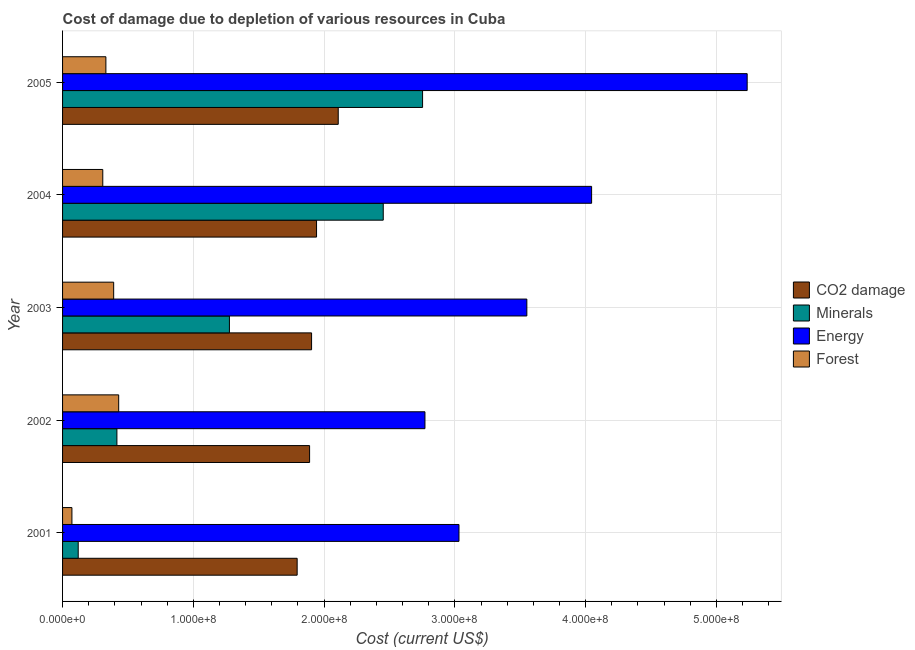How many different coloured bars are there?
Your answer should be compact. 4. Are the number of bars per tick equal to the number of legend labels?
Provide a short and direct response. Yes. Are the number of bars on each tick of the Y-axis equal?
Your response must be concise. Yes. How many bars are there on the 4th tick from the top?
Make the answer very short. 4. What is the label of the 1st group of bars from the top?
Offer a very short reply. 2005. What is the cost of damage due to depletion of forests in 2005?
Give a very brief answer. 3.31e+07. Across all years, what is the maximum cost of damage due to depletion of minerals?
Your response must be concise. 2.75e+08. Across all years, what is the minimum cost of damage due to depletion of forests?
Your answer should be compact. 7.16e+06. What is the total cost of damage due to depletion of minerals in the graph?
Provide a short and direct response. 7.02e+08. What is the difference between the cost of damage due to depletion of coal in 2002 and that in 2003?
Your answer should be very brief. -1.51e+06. What is the difference between the cost of damage due to depletion of energy in 2002 and the cost of damage due to depletion of coal in 2003?
Your response must be concise. 8.67e+07. What is the average cost of damage due to depletion of coal per year?
Keep it short and to the point. 1.93e+08. In the year 2005, what is the difference between the cost of damage due to depletion of coal and cost of damage due to depletion of forests?
Provide a short and direct response. 1.78e+08. What is the ratio of the cost of damage due to depletion of coal in 2004 to that in 2005?
Your response must be concise. 0.92. What is the difference between the highest and the second highest cost of damage due to depletion of energy?
Provide a succinct answer. 1.19e+08. What is the difference between the highest and the lowest cost of damage due to depletion of coal?
Ensure brevity in your answer.  3.14e+07. In how many years, is the cost of damage due to depletion of forests greater than the average cost of damage due to depletion of forests taken over all years?
Your answer should be compact. 4. What does the 2nd bar from the top in 2005 represents?
Give a very brief answer. Energy. What does the 2nd bar from the bottom in 2005 represents?
Your response must be concise. Minerals. How many bars are there?
Keep it short and to the point. 20. Are all the bars in the graph horizontal?
Offer a very short reply. Yes. Does the graph contain grids?
Make the answer very short. Yes. How are the legend labels stacked?
Provide a succinct answer. Vertical. What is the title of the graph?
Offer a terse response. Cost of damage due to depletion of various resources in Cuba . Does "UNTA" appear as one of the legend labels in the graph?
Offer a very short reply. No. What is the label or title of the X-axis?
Your answer should be very brief. Cost (current US$). What is the Cost (current US$) in CO2 damage in 2001?
Make the answer very short. 1.79e+08. What is the Cost (current US$) of Minerals in 2001?
Offer a very short reply. 1.20e+07. What is the Cost (current US$) of Energy in 2001?
Offer a terse response. 3.03e+08. What is the Cost (current US$) in Forest in 2001?
Make the answer very short. 7.16e+06. What is the Cost (current US$) of CO2 damage in 2002?
Give a very brief answer. 1.89e+08. What is the Cost (current US$) of Minerals in 2002?
Give a very brief answer. 4.16e+07. What is the Cost (current US$) of Energy in 2002?
Give a very brief answer. 2.77e+08. What is the Cost (current US$) in Forest in 2002?
Ensure brevity in your answer.  4.29e+07. What is the Cost (current US$) of CO2 damage in 2003?
Your answer should be very brief. 1.90e+08. What is the Cost (current US$) of Minerals in 2003?
Provide a succinct answer. 1.28e+08. What is the Cost (current US$) in Energy in 2003?
Provide a succinct answer. 3.55e+08. What is the Cost (current US$) of Forest in 2003?
Your response must be concise. 3.91e+07. What is the Cost (current US$) of CO2 damage in 2004?
Offer a very short reply. 1.94e+08. What is the Cost (current US$) in Minerals in 2004?
Ensure brevity in your answer.  2.45e+08. What is the Cost (current US$) in Energy in 2004?
Ensure brevity in your answer.  4.05e+08. What is the Cost (current US$) in Forest in 2004?
Keep it short and to the point. 3.08e+07. What is the Cost (current US$) of CO2 damage in 2005?
Your answer should be compact. 2.11e+08. What is the Cost (current US$) in Minerals in 2005?
Give a very brief answer. 2.75e+08. What is the Cost (current US$) of Energy in 2005?
Your answer should be very brief. 5.24e+08. What is the Cost (current US$) of Forest in 2005?
Offer a terse response. 3.31e+07. Across all years, what is the maximum Cost (current US$) of CO2 damage?
Your response must be concise. 2.11e+08. Across all years, what is the maximum Cost (current US$) of Minerals?
Offer a very short reply. 2.75e+08. Across all years, what is the maximum Cost (current US$) in Energy?
Offer a very short reply. 5.24e+08. Across all years, what is the maximum Cost (current US$) of Forest?
Make the answer very short. 4.29e+07. Across all years, what is the minimum Cost (current US$) in CO2 damage?
Give a very brief answer. 1.79e+08. Across all years, what is the minimum Cost (current US$) in Minerals?
Your response must be concise. 1.20e+07. Across all years, what is the minimum Cost (current US$) in Energy?
Your answer should be compact. 2.77e+08. Across all years, what is the minimum Cost (current US$) of Forest?
Provide a short and direct response. 7.16e+06. What is the total Cost (current US$) of CO2 damage in the graph?
Offer a terse response. 9.64e+08. What is the total Cost (current US$) of Minerals in the graph?
Your answer should be very brief. 7.02e+08. What is the total Cost (current US$) in Energy in the graph?
Make the answer very short. 1.86e+09. What is the total Cost (current US$) in Forest in the graph?
Provide a succinct answer. 1.53e+08. What is the difference between the Cost (current US$) of CO2 damage in 2001 and that in 2002?
Give a very brief answer. -9.51e+06. What is the difference between the Cost (current US$) of Minerals in 2001 and that in 2002?
Make the answer very short. -2.96e+07. What is the difference between the Cost (current US$) of Energy in 2001 and that in 2002?
Your answer should be compact. 2.60e+07. What is the difference between the Cost (current US$) of Forest in 2001 and that in 2002?
Your answer should be very brief. -3.58e+07. What is the difference between the Cost (current US$) in CO2 damage in 2001 and that in 2003?
Ensure brevity in your answer.  -1.10e+07. What is the difference between the Cost (current US$) of Minerals in 2001 and that in 2003?
Keep it short and to the point. -1.16e+08. What is the difference between the Cost (current US$) of Energy in 2001 and that in 2003?
Provide a succinct answer. -5.19e+07. What is the difference between the Cost (current US$) in Forest in 2001 and that in 2003?
Your answer should be compact. -3.19e+07. What is the difference between the Cost (current US$) in CO2 damage in 2001 and that in 2004?
Your response must be concise. -1.48e+07. What is the difference between the Cost (current US$) in Minerals in 2001 and that in 2004?
Offer a very short reply. -2.33e+08. What is the difference between the Cost (current US$) of Energy in 2001 and that in 2004?
Your answer should be very brief. -1.01e+08. What is the difference between the Cost (current US$) in Forest in 2001 and that in 2004?
Provide a short and direct response. -2.36e+07. What is the difference between the Cost (current US$) in CO2 damage in 2001 and that in 2005?
Offer a very short reply. -3.14e+07. What is the difference between the Cost (current US$) in Minerals in 2001 and that in 2005?
Your response must be concise. -2.63e+08. What is the difference between the Cost (current US$) of Energy in 2001 and that in 2005?
Your answer should be very brief. -2.20e+08. What is the difference between the Cost (current US$) in Forest in 2001 and that in 2005?
Your answer should be very brief. -2.60e+07. What is the difference between the Cost (current US$) of CO2 damage in 2002 and that in 2003?
Provide a short and direct response. -1.51e+06. What is the difference between the Cost (current US$) in Minerals in 2002 and that in 2003?
Offer a terse response. -8.60e+07. What is the difference between the Cost (current US$) in Energy in 2002 and that in 2003?
Offer a very short reply. -7.79e+07. What is the difference between the Cost (current US$) in Forest in 2002 and that in 2003?
Make the answer very short. 3.83e+06. What is the difference between the Cost (current US$) of CO2 damage in 2002 and that in 2004?
Ensure brevity in your answer.  -5.31e+06. What is the difference between the Cost (current US$) of Minerals in 2002 and that in 2004?
Provide a succinct answer. -2.04e+08. What is the difference between the Cost (current US$) in Energy in 2002 and that in 2004?
Your response must be concise. -1.27e+08. What is the difference between the Cost (current US$) in Forest in 2002 and that in 2004?
Offer a terse response. 1.22e+07. What is the difference between the Cost (current US$) of CO2 damage in 2002 and that in 2005?
Offer a very short reply. -2.19e+07. What is the difference between the Cost (current US$) in Minerals in 2002 and that in 2005?
Provide a short and direct response. -2.34e+08. What is the difference between the Cost (current US$) in Energy in 2002 and that in 2005?
Give a very brief answer. -2.46e+08. What is the difference between the Cost (current US$) in Forest in 2002 and that in 2005?
Your answer should be very brief. 9.78e+06. What is the difference between the Cost (current US$) in CO2 damage in 2003 and that in 2004?
Provide a succinct answer. -3.80e+06. What is the difference between the Cost (current US$) of Minerals in 2003 and that in 2004?
Ensure brevity in your answer.  -1.18e+08. What is the difference between the Cost (current US$) of Energy in 2003 and that in 2004?
Your answer should be compact. -4.95e+07. What is the difference between the Cost (current US$) in Forest in 2003 and that in 2004?
Your response must be concise. 8.33e+06. What is the difference between the Cost (current US$) of CO2 damage in 2003 and that in 2005?
Your answer should be very brief. -2.04e+07. What is the difference between the Cost (current US$) in Minerals in 2003 and that in 2005?
Ensure brevity in your answer.  -1.48e+08. What is the difference between the Cost (current US$) of Energy in 2003 and that in 2005?
Give a very brief answer. -1.68e+08. What is the difference between the Cost (current US$) in Forest in 2003 and that in 2005?
Offer a very short reply. 5.95e+06. What is the difference between the Cost (current US$) in CO2 damage in 2004 and that in 2005?
Ensure brevity in your answer.  -1.66e+07. What is the difference between the Cost (current US$) in Minerals in 2004 and that in 2005?
Provide a succinct answer. -3.01e+07. What is the difference between the Cost (current US$) in Energy in 2004 and that in 2005?
Keep it short and to the point. -1.19e+08. What is the difference between the Cost (current US$) of Forest in 2004 and that in 2005?
Offer a terse response. -2.38e+06. What is the difference between the Cost (current US$) in CO2 damage in 2001 and the Cost (current US$) in Minerals in 2002?
Ensure brevity in your answer.  1.38e+08. What is the difference between the Cost (current US$) of CO2 damage in 2001 and the Cost (current US$) of Energy in 2002?
Provide a short and direct response. -9.77e+07. What is the difference between the Cost (current US$) in CO2 damage in 2001 and the Cost (current US$) in Forest in 2002?
Provide a short and direct response. 1.36e+08. What is the difference between the Cost (current US$) in Minerals in 2001 and the Cost (current US$) in Energy in 2002?
Your response must be concise. -2.65e+08. What is the difference between the Cost (current US$) in Minerals in 2001 and the Cost (current US$) in Forest in 2002?
Make the answer very short. -3.09e+07. What is the difference between the Cost (current US$) of Energy in 2001 and the Cost (current US$) of Forest in 2002?
Ensure brevity in your answer.  2.60e+08. What is the difference between the Cost (current US$) of CO2 damage in 2001 and the Cost (current US$) of Minerals in 2003?
Your answer should be compact. 5.18e+07. What is the difference between the Cost (current US$) in CO2 damage in 2001 and the Cost (current US$) in Energy in 2003?
Make the answer very short. -1.76e+08. What is the difference between the Cost (current US$) in CO2 damage in 2001 and the Cost (current US$) in Forest in 2003?
Provide a succinct answer. 1.40e+08. What is the difference between the Cost (current US$) in Minerals in 2001 and the Cost (current US$) in Energy in 2003?
Offer a very short reply. -3.43e+08. What is the difference between the Cost (current US$) in Minerals in 2001 and the Cost (current US$) in Forest in 2003?
Offer a very short reply. -2.71e+07. What is the difference between the Cost (current US$) of Energy in 2001 and the Cost (current US$) of Forest in 2003?
Make the answer very short. 2.64e+08. What is the difference between the Cost (current US$) in CO2 damage in 2001 and the Cost (current US$) in Minerals in 2004?
Offer a very short reply. -6.58e+07. What is the difference between the Cost (current US$) of CO2 damage in 2001 and the Cost (current US$) of Energy in 2004?
Your answer should be very brief. -2.25e+08. What is the difference between the Cost (current US$) in CO2 damage in 2001 and the Cost (current US$) in Forest in 2004?
Your answer should be compact. 1.49e+08. What is the difference between the Cost (current US$) in Minerals in 2001 and the Cost (current US$) in Energy in 2004?
Your response must be concise. -3.93e+08. What is the difference between the Cost (current US$) in Minerals in 2001 and the Cost (current US$) in Forest in 2004?
Your answer should be very brief. -1.88e+07. What is the difference between the Cost (current US$) of Energy in 2001 and the Cost (current US$) of Forest in 2004?
Offer a very short reply. 2.72e+08. What is the difference between the Cost (current US$) of CO2 damage in 2001 and the Cost (current US$) of Minerals in 2005?
Your response must be concise. -9.59e+07. What is the difference between the Cost (current US$) in CO2 damage in 2001 and the Cost (current US$) in Energy in 2005?
Make the answer very short. -3.44e+08. What is the difference between the Cost (current US$) of CO2 damage in 2001 and the Cost (current US$) of Forest in 2005?
Your answer should be compact. 1.46e+08. What is the difference between the Cost (current US$) of Minerals in 2001 and the Cost (current US$) of Energy in 2005?
Your response must be concise. -5.12e+08. What is the difference between the Cost (current US$) in Minerals in 2001 and the Cost (current US$) in Forest in 2005?
Give a very brief answer. -2.12e+07. What is the difference between the Cost (current US$) in Energy in 2001 and the Cost (current US$) in Forest in 2005?
Make the answer very short. 2.70e+08. What is the difference between the Cost (current US$) of CO2 damage in 2002 and the Cost (current US$) of Minerals in 2003?
Your answer should be very brief. 6.13e+07. What is the difference between the Cost (current US$) in CO2 damage in 2002 and the Cost (current US$) in Energy in 2003?
Keep it short and to the point. -1.66e+08. What is the difference between the Cost (current US$) of CO2 damage in 2002 and the Cost (current US$) of Forest in 2003?
Your answer should be compact. 1.50e+08. What is the difference between the Cost (current US$) of Minerals in 2002 and the Cost (current US$) of Energy in 2003?
Your answer should be very brief. -3.13e+08. What is the difference between the Cost (current US$) of Minerals in 2002 and the Cost (current US$) of Forest in 2003?
Provide a succinct answer. 2.47e+06. What is the difference between the Cost (current US$) in Energy in 2002 and the Cost (current US$) in Forest in 2003?
Give a very brief answer. 2.38e+08. What is the difference between the Cost (current US$) of CO2 damage in 2002 and the Cost (current US$) of Minerals in 2004?
Make the answer very short. -5.63e+07. What is the difference between the Cost (current US$) of CO2 damage in 2002 and the Cost (current US$) of Energy in 2004?
Your answer should be compact. -2.16e+08. What is the difference between the Cost (current US$) in CO2 damage in 2002 and the Cost (current US$) in Forest in 2004?
Your response must be concise. 1.58e+08. What is the difference between the Cost (current US$) of Minerals in 2002 and the Cost (current US$) of Energy in 2004?
Provide a succinct answer. -3.63e+08. What is the difference between the Cost (current US$) of Minerals in 2002 and the Cost (current US$) of Forest in 2004?
Keep it short and to the point. 1.08e+07. What is the difference between the Cost (current US$) of Energy in 2002 and the Cost (current US$) of Forest in 2004?
Ensure brevity in your answer.  2.46e+08. What is the difference between the Cost (current US$) in CO2 damage in 2002 and the Cost (current US$) in Minerals in 2005?
Make the answer very short. -8.64e+07. What is the difference between the Cost (current US$) of CO2 damage in 2002 and the Cost (current US$) of Energy in 2005?
Provide a succinct answer. -3.35e+08. What is the difference between the Cost (current US$) of CO2 damage in 2002 and the Cost (current US$) of Forest in 2005?
Offer a very short reply. 1.56e+08. What is the difference between the Cost (current US$) of Minerals in 2002 and the Cost (current US$) of Energy in 2005?
Your answer should be compact. -4.82e+08. What is the difference between the Cost (current US$) of Minerals in 2002 and the Cost (current US$) of Forest in 2005?
Make the answer very short. 8.42e+06. What is the difference between the Cost (current US$) of Energy in 2002 and the Cost (current US$) of Forest in 2005?
Your answer should be compact. 2.44e+08. What is the difference between the Cost (current US$) of CO2 damage in 2003 and the Cost (current US$) of Minerals in 2004?
Offer a terse response. -5.48e+07. What is the difference between the Cost (current US$) in CO2 damage in 2003 and the Cost (current US$) in Energy in 2004?
Ensure brevity in your answer.  -2.14e+08. What is the difference between the Cost (current US$) in CO2 damage in 2003 and the Cost (current US$) in Forest in 2004?
Provide a short and direct response. 1.60e+08. What is the difference between the Cost (current US$) of Minerals in 2003 and the Cost (current US$) of Energy in 2004?
Give a very brief answer. -2.77e+08. What is the difference between the Cost (current US$) of Minerals in 2003 and the Cost (current US$) of Forest in 2004?
Offer a terse response. 9.68e+07. What is the difference between the Cost (current US$) of Energy in 2003 and the Cost (current US$) of Forest in 2004?
Your answer should be very brief. 3.24e+08. What is the difference between the Cost (current US$) in CO2 damage in 2003 and the Cost (current US$) in Minerals in 2005?
Your answer should be compact. -8.49e+07. What is the difference between the Cost (current US$) of CO2 damage in 2003 and the Cost (current US$) of Energy in 2005?
Provide a short and direct response. -3.33e+08. What is the difference between the Cost (current US$) in CO2 damage in 2003 and the Cost (current US$) in Forest in 2005?
Your response must be concise. 1.57e+08. What is the difference between the Cost (current US$) of Minerals in 2003 and the Cost (current US$) of Energy in 2005?
Your response must be concise. -3.96e+08. What is the difference between the Cost (current US$) in Minerals in 2003 and the Cost (current US$) in Forest in 2005?
Offer a terse response. 9.45e+07. What is the difference between the Cost (current US$) of Energy in 2003 and the Cost (current US$) of Forest in 2005?
Offer a terse response. 3.22e+08. What is the difference between the Cost (current US$) in CO2 damage in 2004 and the Cost (current US$) in Minerals in 2005?
Provide a succinct answer. -8.11e+07. What is the difference between the Cost (current US$) of CO2 damage in 2004 and the Cost (current US$) of Energy in 2005?
Provide a short and direct response. -3.29e+08. What is the difference between the Cost (current US$) of CO2 damage in 2004 and the Cost (current US$) of Forest in 2005?
Give a very brief answer. 1.61e+08. What is the difference between the Cost (current US$) in Minerals in 2004 and the Cost (current US$) in Energy in 2005?
Your response must be concise. -2.78e+08. What is the difference between the Cost (current US$) of Minerals in 2004 and the Cost (current US$) of Forest in 2005?
Make the answer very short. 2.12e+08. What is the difference between the Cost (current US$) in Energy in 2004 and the Cost (current US$) in Forest in 2005?
Your answer should be very brief. 3.71e+08. What is the average Cost (current US$) of CO2 damage per year?
Ensure brevity in your answer.  1.93e+08. What is the average Cost (current US$) in Minerals per year?
Provide a short and direct response. 1.40e+08. What is the average Cost (current US$) of Energy per year?
Make the answer very short. 3.73e+08. What is the average Cost (current US$) in Forest per year?
Offer a terse response. 3.06e+07. In the year 2001, what is the difference between the Cost (current US$) of CO2 damage and Cost (current US$) of Minerals?
Keep it short and to the point. 1.67e+08. In the year 2001, what is the difference between the Cost (current US$) of CO2 damage and Cost (current US$) of Energy?
Provide a short and direct response. -1.24e+08. In the year 2001, what is the difference between the Cost (current US$) in CO2 damage and Cost (current US$) in Forest?
Offer a very short reply. 1.72e+08. In the year 2001, what is the difference between the Cost (current US$) of Minerals and Cost (current US$) of Energy?
Keep it short and to the point. -2.91e+08. In the year 2001, what is the difference between the Cost (current US$) in Minerals and Cost (current US$) in Forest?
Offer a terse response. 4.81e+06. In the year 2001, what is the difference between the Cost (current US$) in Energy and Cost (current US$) in Forest?
Provide a short and direct response. 2.96e+08. In the year 2002, what is the difference between the Cost (current US$) of CO2 damage and Cost (current US$) of Minerals?
Your answer should be very brief. 1.47e+08. In the year 2002, what is the difference between the Cost (current US$) in CO2 damage and Cost (current US$) in Energy?
Ensure brevity in your answer.  -8.82e+07. In the year 2002, what is the difference between the Cost (current US$) of CO2 damage and Cost (current US$) of Forest?
Provide a short and direct response. 1.46e+08. In the year 2002, what is the difference between the Cost (current US$) of Minerals and Cost (current US$) of Energy?
Make the answer very short. -2.36e+08. In the year 2002, what is the difference between the Cost (current US$) in Minerals and Cost (current US$) in Forest?
Your answer should be compact. -1.35e+06. In the year 2002, what is the difference between the Cost (current US$) of Energy and Cost (current US$) of Forest?
Your response must be concise. 2.34e+08. In the year 2003, what is the difference between the Cost (current US$) of CO2 damage and Cost (current US$) of Minerals?
Provide a succinct answer. 6.28e+07. In the year 2003, what is the difference between the Cost (current US$) of CO2 damage and Cost (current US$) of Energy?
Provide a short and direct response. -1.65e+08. In the year 2003, what is the difference between the Cost (current US$) in CO2 damage and Cost (current US$) in Forest?
Ensure brevity in your answer.  1.51e+08. In the year 2003, what is the difference between the Cost (current US$) of Minerals and Cost (current US$) of Energy?
Your answer should be very brief. -2.27e+08. In the year 2003, what is the difference between the Cost (current US$) in Minerals and Cost (current US$) in Forest?
Your answer should be very brief. 8.85e+07. In the year 2003, what is the difference between the Cost (current US$) of Energy and Cost (current US$) of Forest?
Provide a succinct answer. 3.16e+08. In the year 2004, what is the difference between the Cost (current US$) in CO2 damage and Cost (current US$) in Minerals?
Keep it short and to the point. -5.10e+07. In the year 2004, what is the difference between the Cost (current US$) in CO2 damage and Cost (current US$) in Energy?
Offer a very short reply. -2.10e+08. In the year 2004, what is the difference between the Cost (current US$) of CO2 damage and Cost (current US$) of Forest?
Ensure brevity in your answer.  1.63e+08. In the year 2004, what is the difference between the Cost (current US$) in Minerals and Cost (current US$) in Energy?
Ensure brevity in your answer.  -1.59e+08. In the year 2004, what is the difference between the Cost (current US$) in Minerals and Cost (current US$) in Forest?
Provide a succinct answer. 2.14e+08. In the year 2004, what is the difference between the Cost (current US$) of Energy and Cost (current US$) of Forest?
Ensure brevity in your answer.  3.74e+08. In the year 2005, what is the difference between the Cost (current US$) of CO2 damage and Cost (current US$) of Minerals?
Keep it short and to the point. -6.45e+07. In the year 2005, what is the difference between the Cost (current US$) of CO2 damage and Cost (current US$) of Energy?
Your response must be concise. -3.13e+08. In the year 2005, what is the difference between the Cost (current US$) in CO2 damage and Cost (current US$) in Forest?
Offer a very short reply. 1.78e+08. In the year 2005, what is the difference between the Cost (current US$) of Minerals and Cost (current US$) of Energy?
Offer a very short reply. -2.48e+08. In the year 2005, what is the difference between the Cost (current US$) of Minerals and Cost (current US$) of Forest?
Ensure brevity in your answer.  2.42e+08. In the year 2005, what is the difference between the Cost (current US$) of Energy and Cost (current US$) of Forest?
Keep it short and to the point. 4.90e+08. What is the ratio of the Cost (current US$) of CO2 damage in 2001 to that in 2002?
Ensure brevity in your answer.  0.95. What is the ratio of the Cost (current US$) in Minerals in 2001 to that in 2002?
Your answer should be very brief. 0.29. What is the ratio of the Cost (current US$) in Energy in 2001 to that in 2002?
Provide a short and direct response. 1.09. What is the ratio of the Cost (current US$) in Forest in 2001 to that in 2002?
Your response must be concise. 0.17. What is the ratio of the Cost (current US$) of CO2 damage in 2001 to that in 2003?
Provide a short and direct response. 0.94. What is the ratio of the Cost (current US$) in Minerals in 2001 to that in 2003?
Make the answer very short. 0.09. What is the ratio of the Cost (current US$) of Energy in 2001 to that in 2003?
Provide a short and direct response. 0.85. What is the ratio of the Cost (current US$) of Forest in 2001 to that in 2003?
Ensure brevity in your answer.  0.18. What is the ratio of the Cost (current US$) in CO2 damage in 2001 to that in 2004?
Provide a short and direct response. 0.92. What is the ratio of the Cost (current US$) in Minerals in 2001 to that in 2004?
Offer a terse response. 0.05. What is the ratio of the Cost (current US$) of Energy in 2001 to that in 2004?
Your answer should be compact. 0.75. What is the ratio of the Cost (current US$) of Forest in 2001 to that in 2004?
Make the answer very short. 0.23. What is the ratio of the Cost (current US$) of CO2 damage in 2001 to that in 2005?
Your answer should be very brief. 0.85. What is the ratio of the Cost (current US$) of Minerals in 2001 to that in 2005?
Keep it short and to the point. 0.04. What is the ratio of the Cost (current US$) of Energy in 2001 to that in 2005?
Offer a very short reply. 0.58. What is the ratio of the Cost (current US$) in Forest in 2001 to that in 2005?
Ensure brevity in your answer.  0.22. What is the ratio of the Cost (current US$) in CO2 damage in 2002 to that in 2003?
Your answer should be very brief. 0.99. What is the ratio of the Cost (current US$) of Minerals in 2002 to that in 2003?
Make the answer very short. 0.33. What is the ratio of the Cost (current US$) of Energy in 2002 to that in 2003?
Your answer should be very brief. 0.78. What is the ratio of the Cost (current US$) of Forest in 2002 to that in 2003?
Provide a short and direct response. 1.1. What is the ratio of the Cost (current US$) of CO2 damage in 2002 to that in 2004?
Offer a terse response. 0.97. What is the ratio of the Cost (current US$) in Minerals in 2002 to that in 2004?
Make the answer very short. 0.17. What is the ratio of the Cost (current US$) in Energy in 2002 to that in 2004?
Your answer should be compact. 0.69. What is the ratio of the Cost (current US$) in Forest in 2002 to that in 2004?
Your answer should be very brief. 1.4. What is the ratio of the Cost (current US$) in CO2 damage in 2002 to that in 2005?
Provide a succinct answer. 0.9. What is the ratio of the Cost (current US$) of Minerals in 2002 to that in 2005?
Your response must be concise. 0.15. What is the ratio of the Cost (current US$) of Energy in 2002 to that in 2005?
Keep it short and to the point. 0.53. What is the ratio of the Cost (current US$) of Forest in 2002 to that in 2005?
Your answer should be compact. 1.3. What is the ratio of the Cost (current US$) of CO2 damage in 2003 to that in 2004?
Ensure brevity in your answer.  0.98. What is the ratio of the Cost (current US$) in Minerals in 2003 to that in 2004?
Your answer should be compact. 0.52. What is the ratio of the Cost (current US$) of Energy in 2003 to that in 2004?
Keep it short and to the point. 0.88. What is the ratio of the Cost (current US$) in Forest in 2003 to that in 2004?
Make the answer very short. 1.27. What is the ratio of the Cost (current US$) in CO2 damage in 2003 to that in 2005?
Your answer should be compact. 0.9. What is the ratio of the Cost (current US$) in Minerals in 2003 to that in 2005?
Offer a terse response. 0.46. What is the ratio of the Cost (current US$) in Energy in 2003 to that in 2005?
Give a very brief answer. 0.68. What is the ratio of the Cost (current US$) of Forest in 2003 to that in 2005?
Your answer should be compact. 1.18. What is the ratio of the Cost (current US$) in CO2 damage in 2004 to that in 2005?
Keep it short and to the point. 0.92. What is the ratio of the Cost (current US$) of Minerals in 2004 to that in 2005?
Provide a succinct answer. 0.89. What is the ratio of the Cost (current US$) of Energy in 2004 to that in 2005?
Make the answer very short. 0.77. What is the ratio of the Cost (current US$) in Forest in 2004 to that in 2005?
Give a very brief answer. 0.93. What is the difference between the highest and the second highest Cost (current US$) of CO2 damage?
Your answer should be very brief. 1.66e+07. What is the difference between the highest and the second highest Cost (current US$) in Minerals?
Offer a terse response. 3.01e+07. What is the difference between the highest and the second highest Cost (current US$) in Energy?
Offer a very short reply. 1.19e+08. What is the difference between the highest and the second highest Cost (current US$) in Forest?
Make the answer very short. 3.83e+06. What is the difference between the highest and the lowest Cost (current US$) in CO2 damage?
Make the answer very short. 3.14e+07. What is the difference between the highest and the lowest Cost (current US$) in Minerals?
Offer a very short reply. 2.63e+08. What is the difference between the highest and the lowest Cost (current US$) of Energy?
Ensure brevity in your answer.  2.46e+08. What is the difference between the highest and the lowest Cost (current US$) in Forest?
Give a very brief answer. 3.58e+07. 